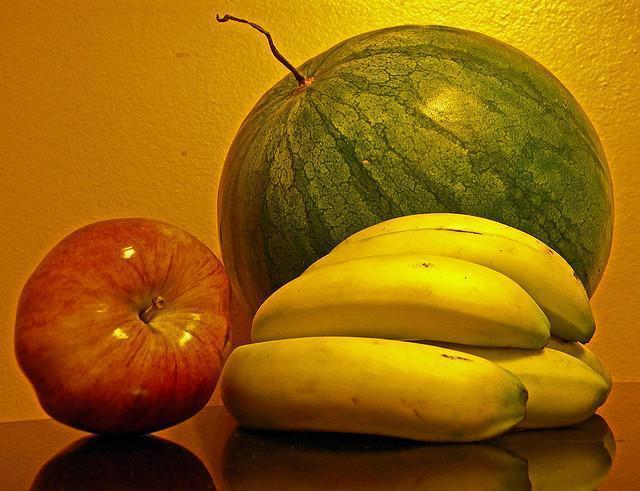Is the caption "The apple is left of the banana." a true representation of the image?
Answer yes or no. Yes. 